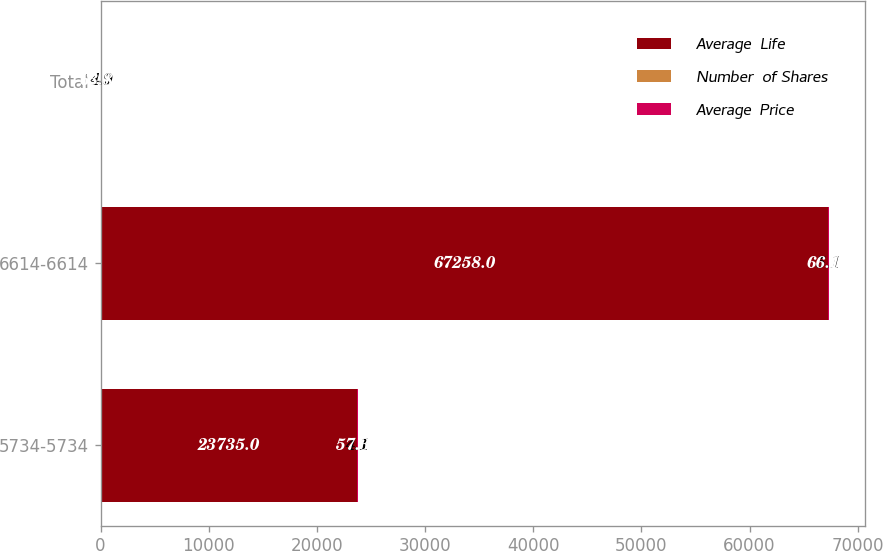Convert chart to OTSL. <chart><loc_0><loc_0><loc_500><loc_500><stacked_bar_chart><ecel><fcel>5734-5734<fcel>6614-6614<fcel>Total<nl><fcel>Average  Life<fcel>23735<fcel>67258<fcel>60.59<nl><fcel>Number  of Shares<fcel>4.1<fcel>5.1<fcel>4.9<nl><fcel>Average  Price<fcel>57.34<fcel>66.14<fcel>63.84<nl></chart> 